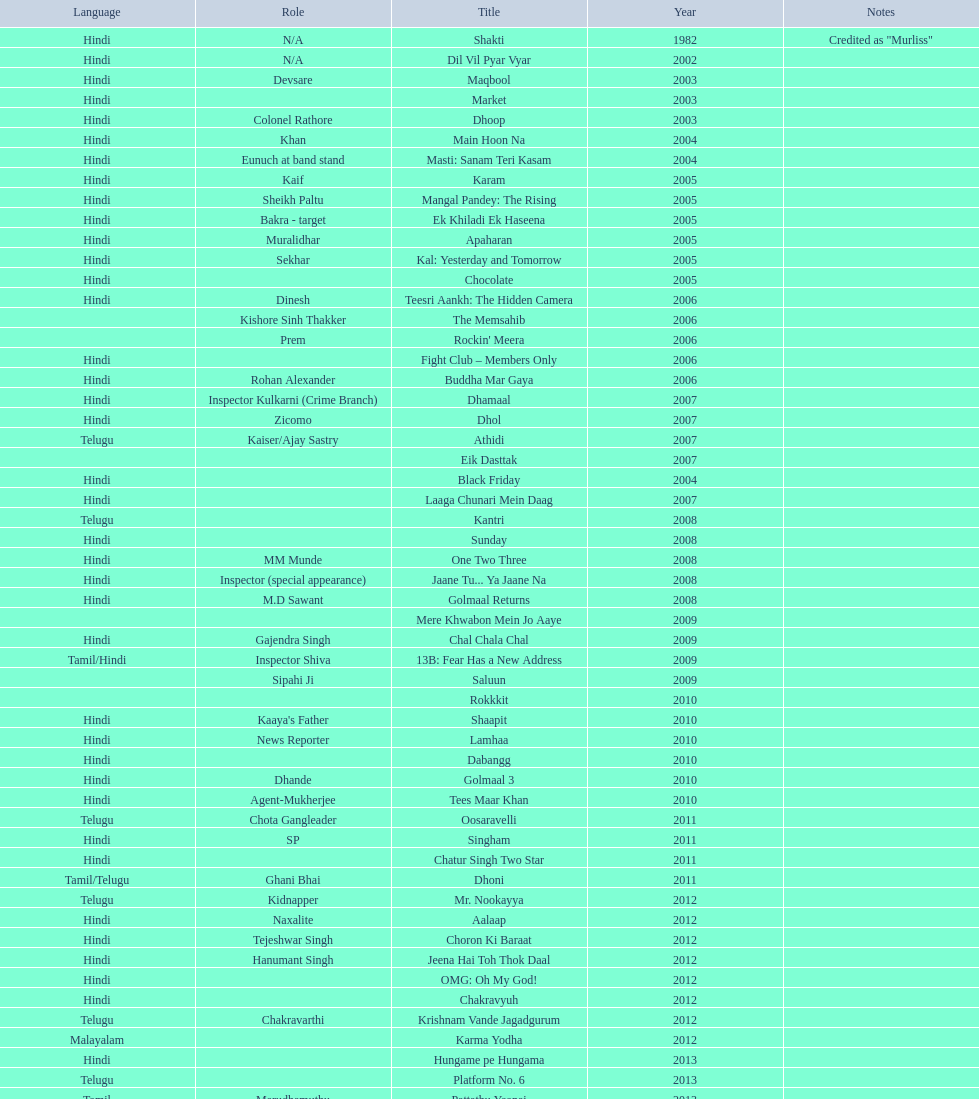What was the last malayalam film this actor starred in? Karma Yodha. 